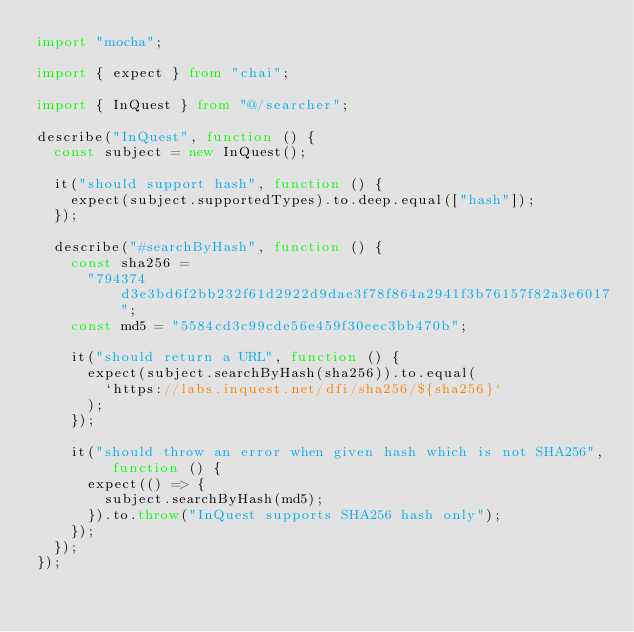Convert code to text. <code><loc_0><loc_0><loc_500><loc_500><_TypeScript_>import "mocha";

import { expect } from "chai";

import { InQuest } from "@/searcher";

describe("InQuest", function () {
  const subject = new InQuest();

  it("should support hash", function () {
    expect(subject.supportedTypes).to.deep.equal(["hash"]);
  });

  describe("#searchByHash", function () {
    const sha256 =
      "794374d3e3bd6f2bb232f61d2922d9dae3f78f864a2941f3b76157f82a3e6017";
    const md5 = "5584cd3c99cde56e459f30eec3bb470b";

    it("should return a URL", function () {
      expect(subject.searchByHash(sha256)).to.equal(
        `https://labs.inquest.net/dfi/sha256/${sha256}`
      );
    });

    it("should throw an error when given hash which is not SHA256", function () {
      expect(() => {
        subject.searchByHash(md5);
      }).to.throw("InQuest supports SHA256 hash only");
    });
  });
});
</code> 